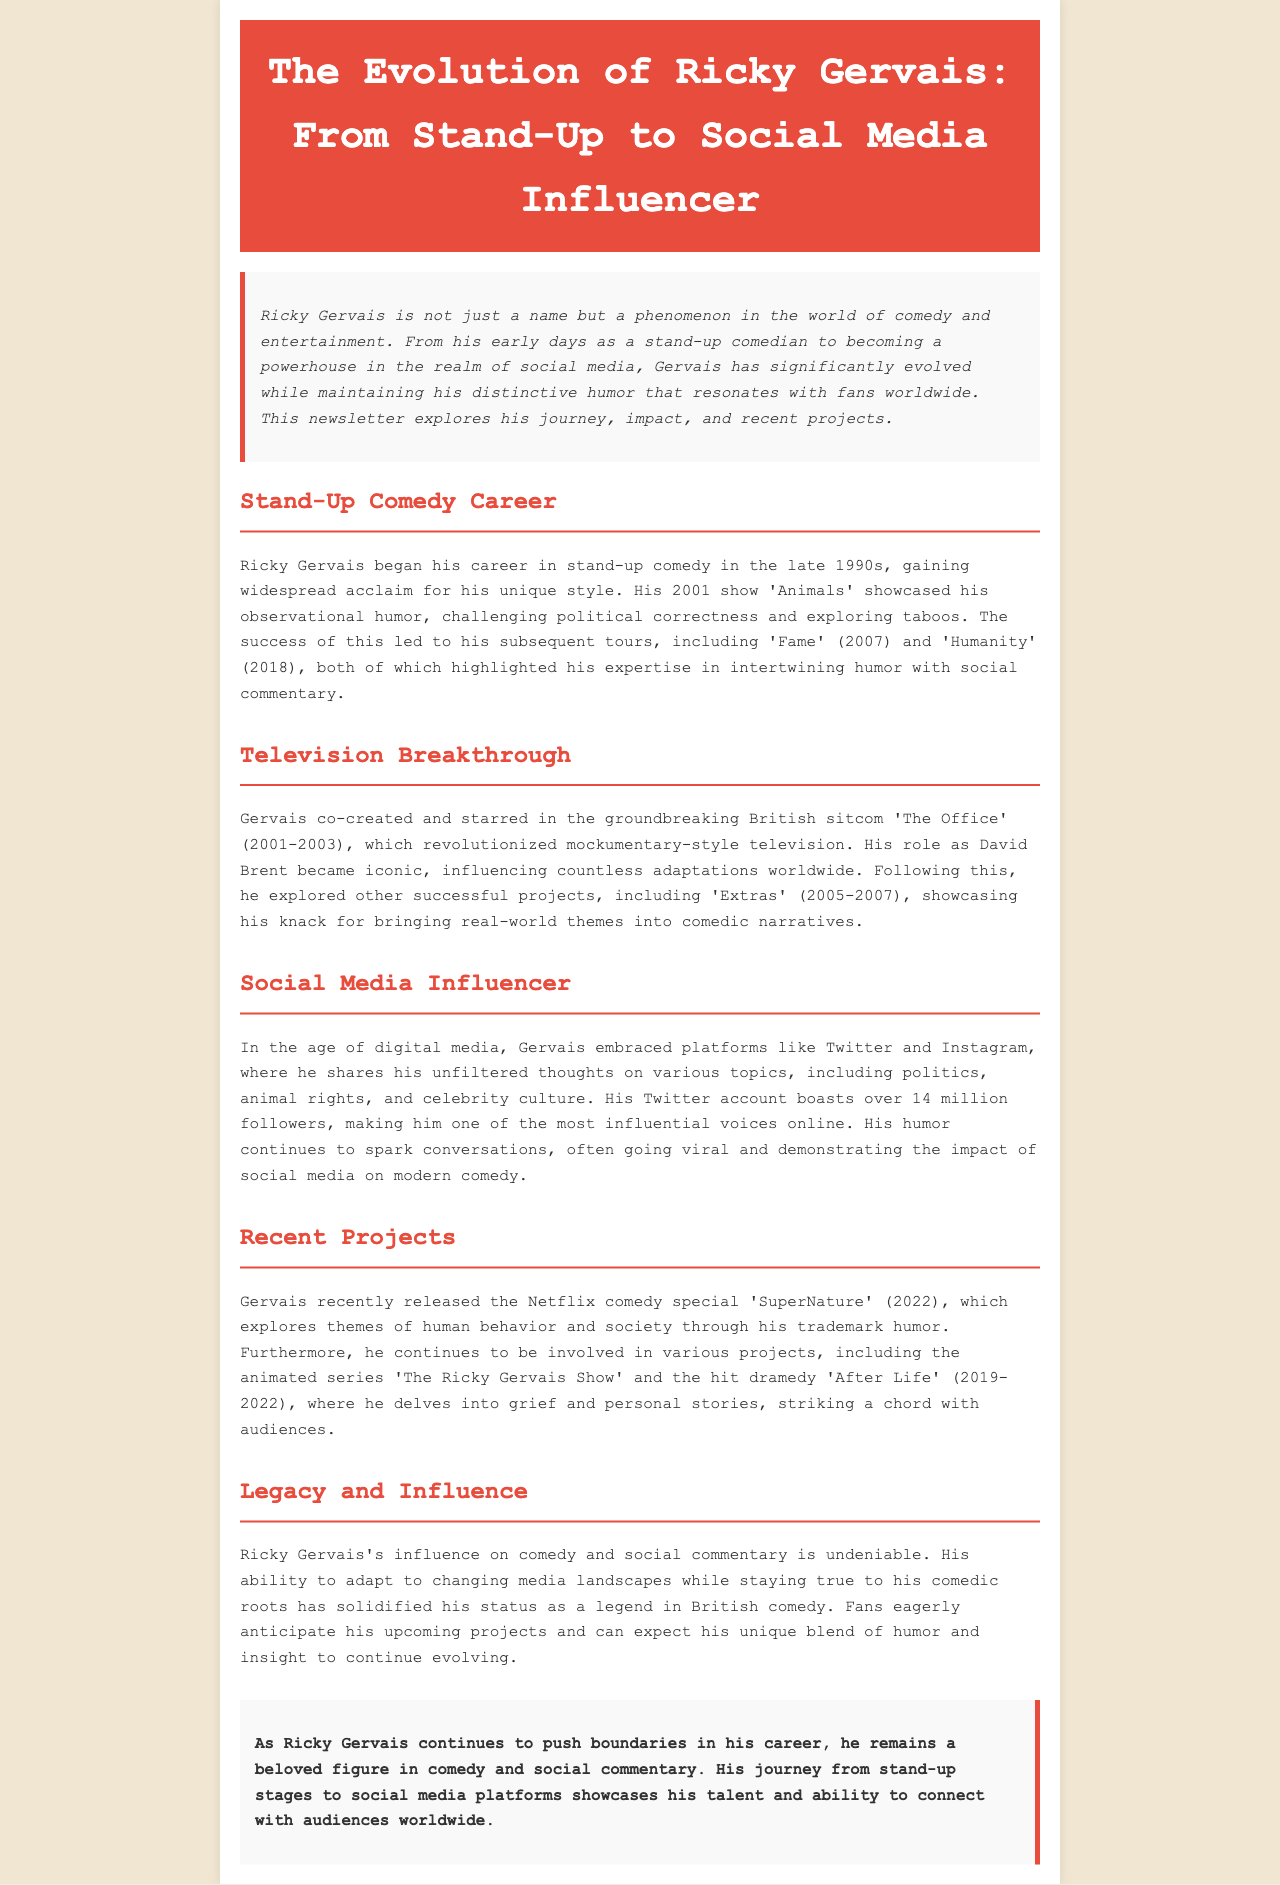What year did Ricky Gervais's show 'Animals' premiere? The document states that 'Animals' was showcased in 2001.
Answer: 2001 How many followers does Ricky Gervais have on Twitter? The document mentions that his Twitter account boasts over 14 million followers.
Answer: 14 million What is the title of Ricky Gervais's recent Netflix comedy special? The document lists the Netflix comedy special as 'SuperNature' (2022).
Answer: SuperNature What significant sitcom did Gervais co-create in 2001? The document identifies 'The Office' as the groundbreaking sitcom he co-created.
Answer: The Office What genre does the animated series 'The Ricky Gervais Show' belong to? The document implies that it is an animated series, fitting within comedic context.
Answer: Animated series How does Ricky Gervais use social media according to the document? The document states he shares unfiltered thoughts on various topics.
Answer: Unfiltered thoughts What comedy style did Gervais utilize in 'Animals'? The document describes his style as observational humor.
Answer: Observational humor What overarching themes does Gervais explore in 'After Life'? The document indicates he delves into grief and personal stories.
Answer: Grief and personal stories 